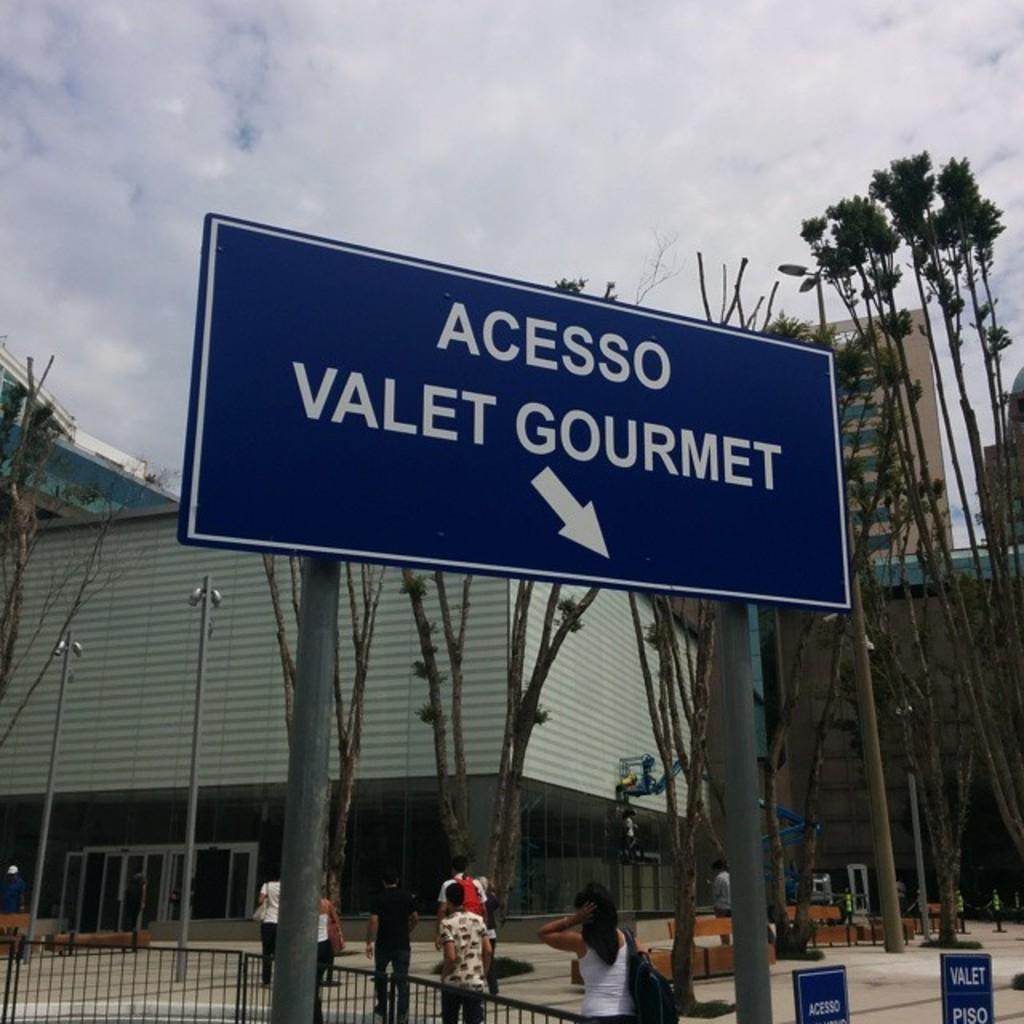Provide a one-sentence caption for the provided image. A blue city street sign that points towards Acesso Valet Gourmet. 